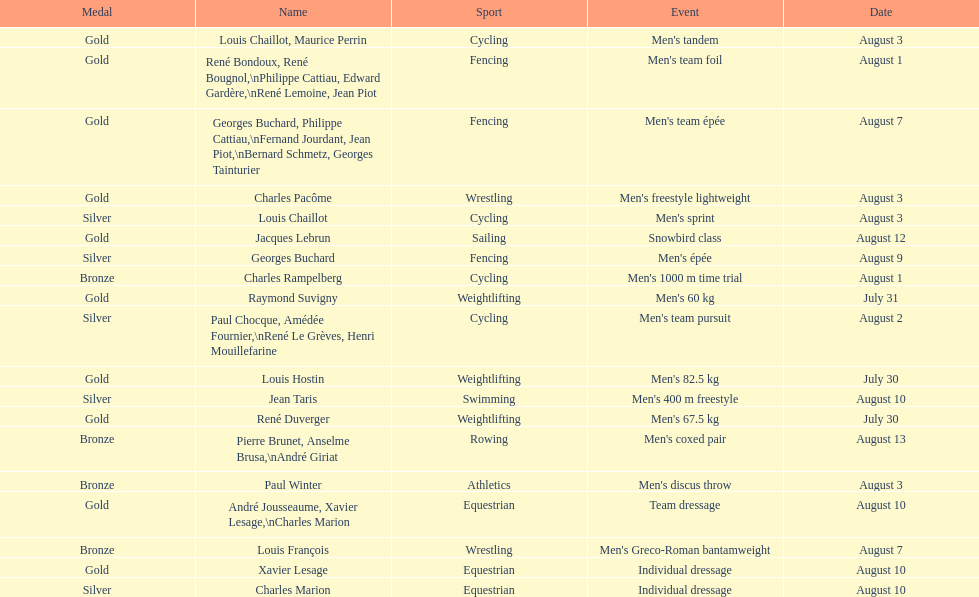Was there more gold medals won than silver? Yes. 